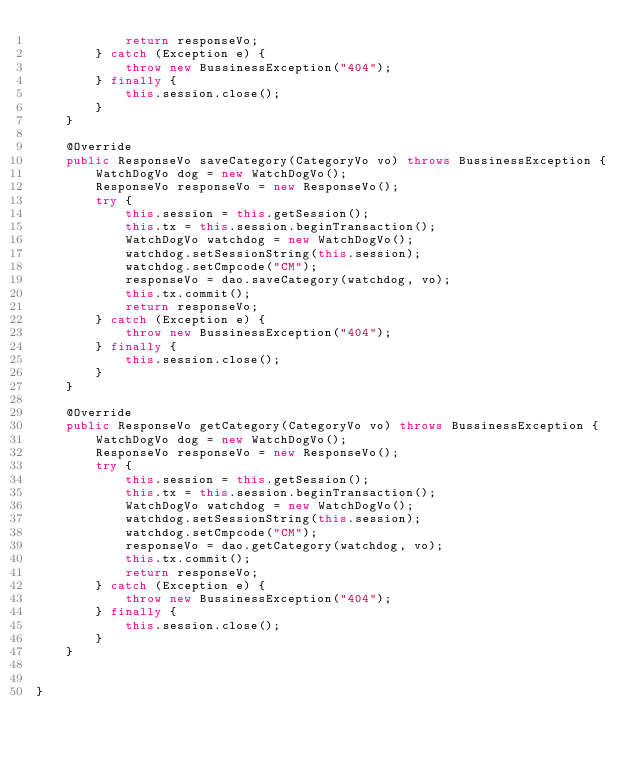<code> <loc_0><loc_0><loc_500><loc_500><_Java_>			return responseVo;
		} catch (Exception e) {
			throw new BussinessException("404");
		} finally {
			this.session.close();
		}
	}

	@Override
	public ResponseVo saveCategory(CategoryVo vo) throws BussinessException {
		WatchDogVo dog = new WatchDogVo();
		ResponseVo responseVo = new ResponseVo();
		try {
			this.session = this.getSession();
			this.tx = this.session.beginTransaction();
			WatchDogVo watchdog = new WatchDogVo();
			watchdog.setSessionString(this.session);
			watchdog.setCmpcode("CM");
			responseVo = dao.saveCategory(watchdog, vo);
			this.tx.commit();
			return responseVo;
		} catch (Exception e) {
			throw new BussinessException("404");
		} finally {
			this.session.close();
		}
	}

	@Override
	public ResponseVo getCategory(CategoryVo vo) throws BussinessException {
		WatchDogVo dog = new WatchDogVo();
		ResponseVo responseVo = new ResponseVo();
		try {
			this.session = this.getSession();
			this.tx = this.session.beginTransaction();
			WatchDogVo watchdog = new WatchDogVo();
			watchdog.setSessionString(this.session);
			watchdog.setCmpcode("CM");
			responseVo = dao.getCategory(watchdog, vo);
			this.tx.commit();
			return responseVo;
		} catch (Exception e) {
			throw new BussinessException("404");
		} finally {
			this.session.close();
		}
	}
 

}
</code> 